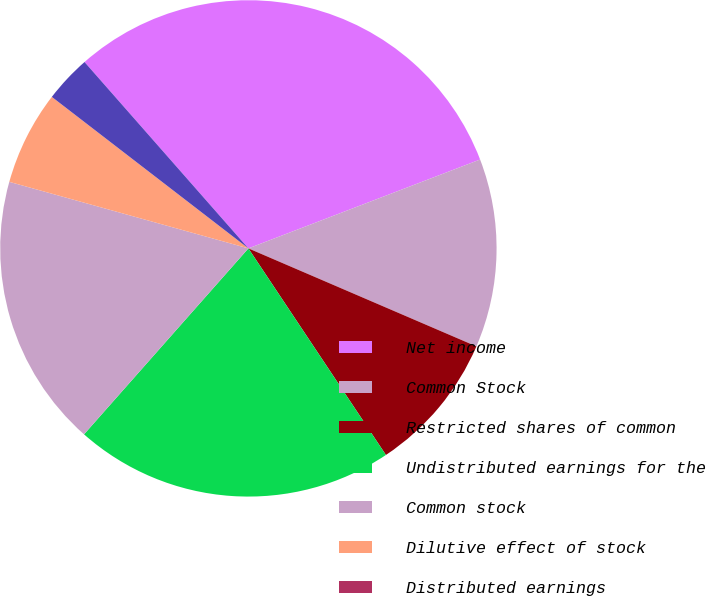Convert chart. <chart><loc_0><loc_0><loc_500><loc_500><pie_chart><fcel>Net income<fcel>Common Stock<fcel>Restricted shares of common<fcel>Undistributed earnings for the<fcel>Common stock<fcel>Dilutive effect of stock<fcel>Distributed earnings<fcel>Undistributed earnings<nl><fcel>30.65%<fcel>12.29%<fcel>9.19%<fcel>20.87%<fcel>17.8%<fcel>6.13%<fcel>0.0%<fcel>3.07%<nl></chart> 